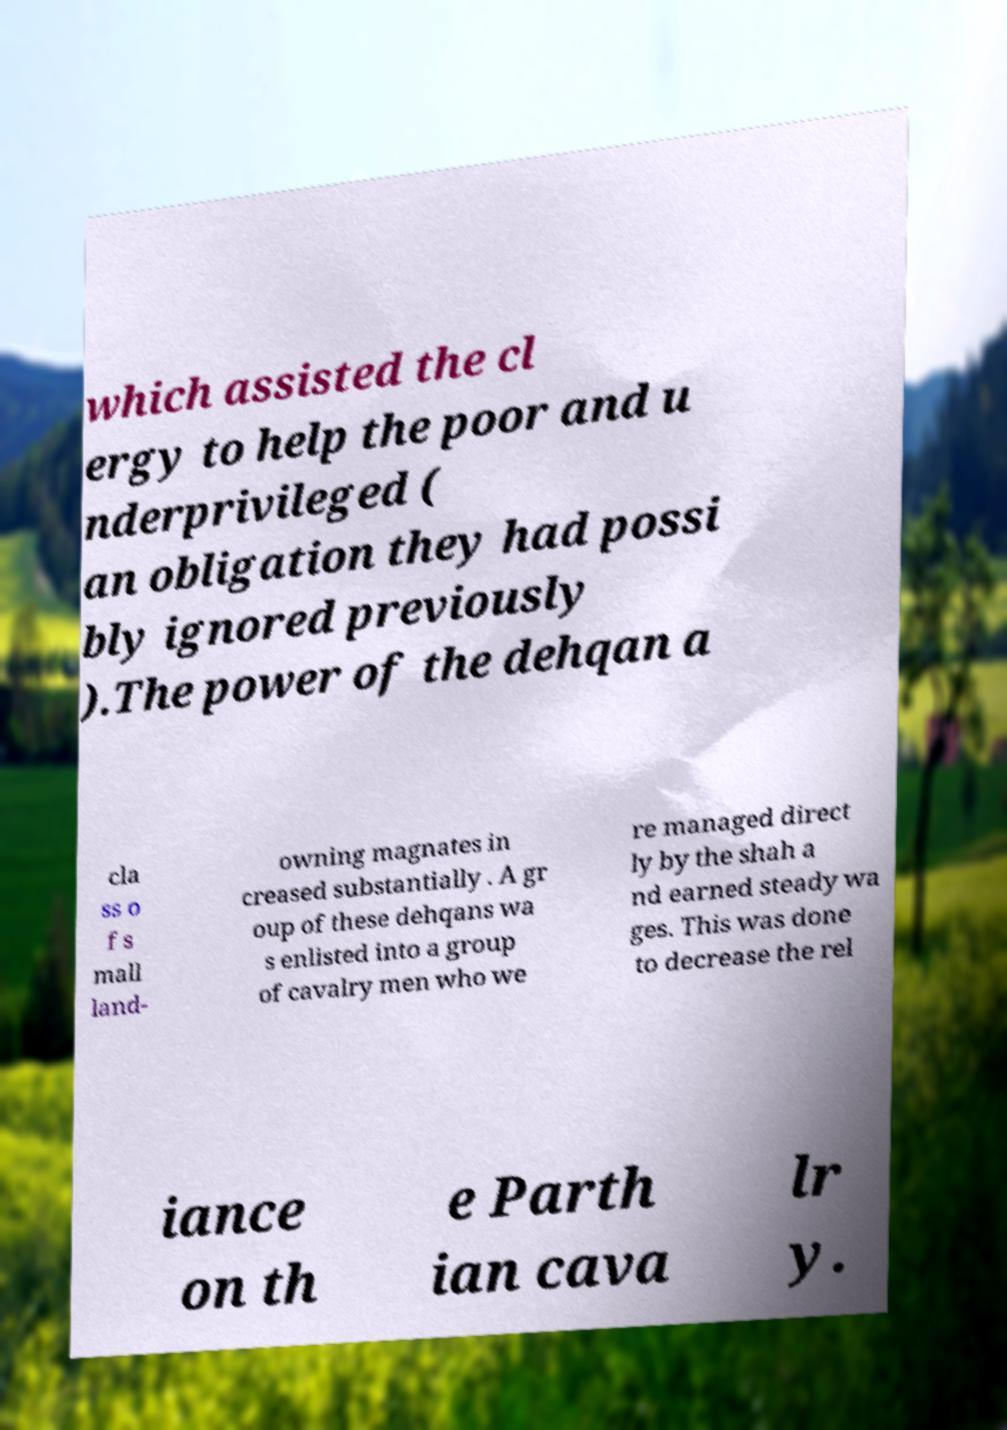Could you extract and type out the text from this image? which assisted the cl ergy to help the poor and u nderprivileged ( an obligation they had possi bly ignored previously ).The power of the dehqan a cla ss o f s mall land- owning magnates in creased substantially . A gr oup of these dehqans wa s enlisted into a group of cavalry men who we re managed direct ly by the shah a nd earned steady wa ges. This was done to decrease the rel iance on th e Parth ian cava lr y. 